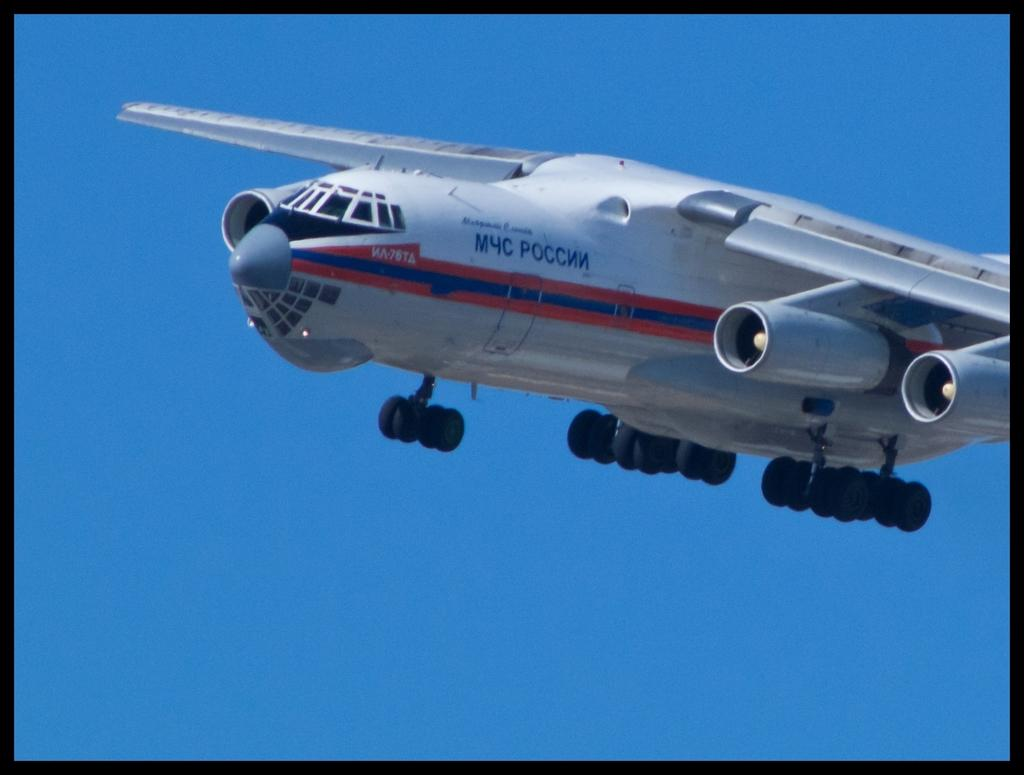What type of image is being shown? The image is an edited picture. What can be seen in the sky in the image? There is an airplane flying in the sky in the image. What kind of pet is visible in the image? There is no pet visible in the image; it features an airplane flying in the sky. How many bikes are present in the image? There are no bikes present in the image; it features an airplane flying in the sky. 